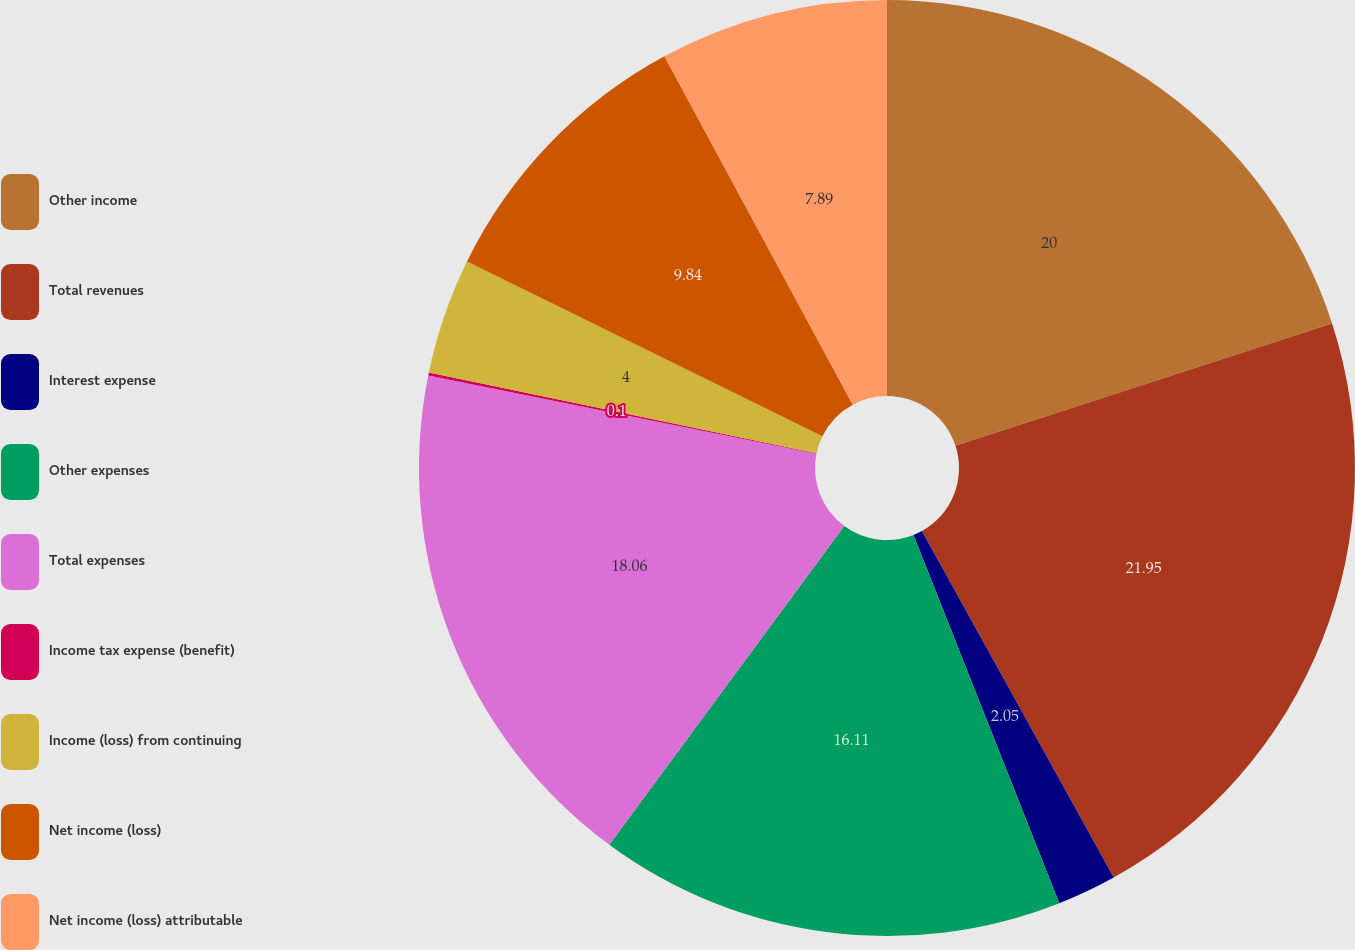<chart> <loc_0><loc_0><loc_500><loc_500><pie_chart><fcel>Other income<fcel>Total revenues<fcel>Interest expense<fcel>Other expenses<fcel>Total expenses<fcel>Income tax expense (benefit)<fcel>Income (loss) from continuing<fcel>Net income (loss)<fcel>Net income (loss) attributable<nl><fcel>20.0%<fcel>21.95%<fcel>2.05%<fcel>16.11%<fcel>18.06%<fcel>0.1%<fcel>4.0%<fcel>9.84%<fcel>7.89%<nl></chart> 